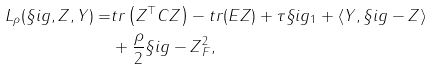Convert formula to latex. <formula><loc_0><loc_0><loc_500><loc_500>L _ { \rho } ( \S i g , Z , Y ) = & t r \left ( Z ^ { \top } C Z \right ) - t r ( E Z ) + \tau \| \S i g \| _ { 1 } + \langle Y , \S i g - Z \rangle \\ & + \frac { \rho } { 2 } \| \S i g - Z \| _ { F } ^ { 2 } ,</formula> 